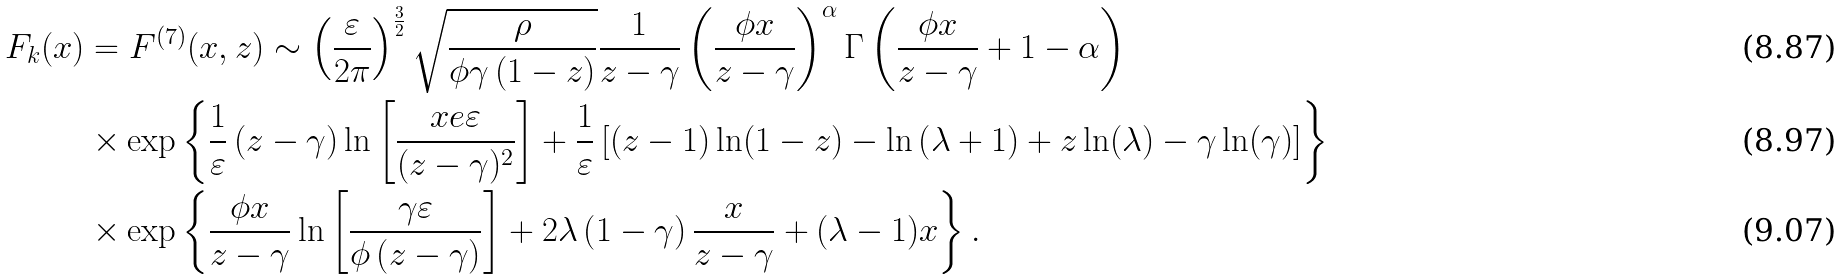<formula> <loc_0><loc_0><loc_500><loc_500>F _ { k } ( x ) & = F ^ { ( 7 ) } ( x , z ) \sim \left ( \frac { \varepsilon } { 2 \pi } \right ) ^ { \frac { 3 } { 2 } } \sqrt { \frac { \rho } { \phi \gamma \left ( 1 - z \right ) } } \frac { 1 } { z - \gamma } \left ( \frac { \phi x } { z - \gamma } \right ) ^ { \alpha } \Gamma \left ( \frac { \phi x } { z - \gamma } + 1 - \alpha \right ) \\ & \times \exp \left \{ \frac { 1 } { \varepsilon } \left ( z - \gamma \right ) \ln \left [ \frac { x e \varepsilon } { ( z - \gamma ) ^ { 2 } } \right ] + \frac { 1 } { \varepsilon } \left [ ( z - 1 ) \ln ( 1 - z ) - \ln \left ( \lambda + 1 \right ) + z \ln ( \lambda ) - \gamma \ln ( \gamma ) \right ] \right \} \\ & \times \exp \left \{ \frac { \phi x } { z - \gamma } \ln \left [ \frac { \gamma \varepsilon } { \phi \left ( z - \gamma \right ) } \right ] + 2 \lambda \left ( 1 - \gamma \right ) \frac { x } { z - \gamma } + ( \lambda - 1 ) x \right \} .</formula> 